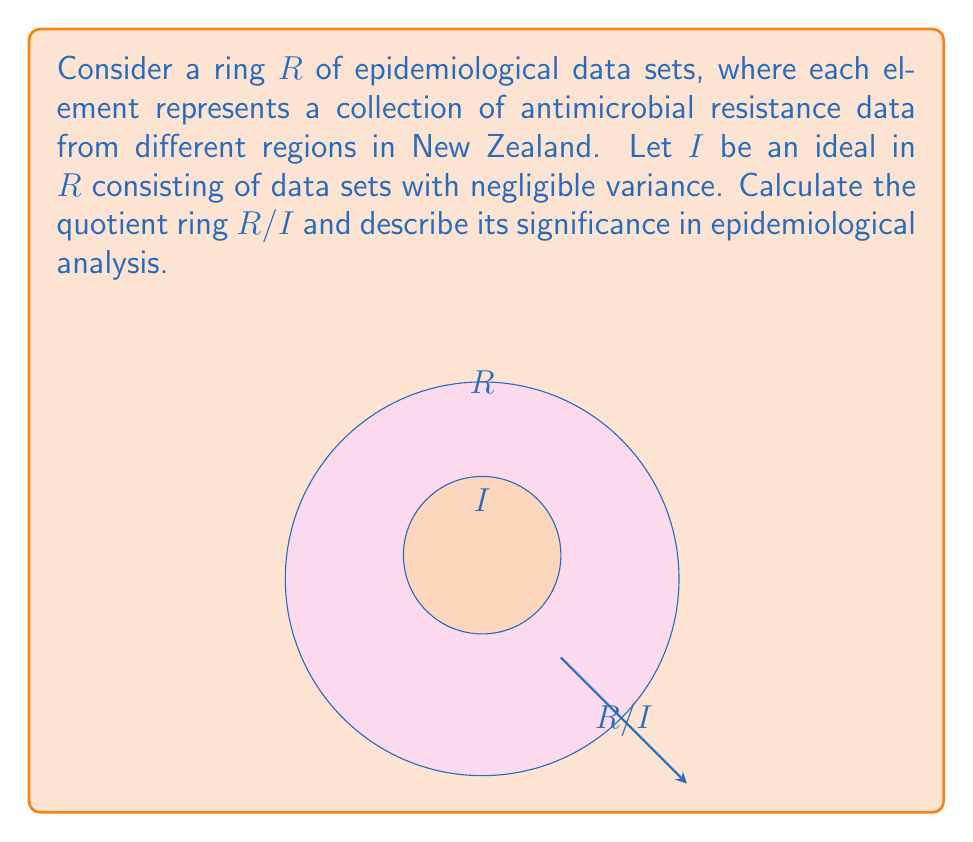What is the answer to this math problem? To calculate the quotient ring $R/I$, we follow these steps:

1) First, recall that the quotient ring $R/I$ is defined as the set of all cosets of $I$ in $R$. Each coset has the form $r + I$ for $r \in R$.

2) In this context, $R$ represents all possible antimicrobial resistance data sets from New Zealand regions, while $I$ represents the subset of these data sets with negligible variance.

3) The elements of $R/I$ are equivalence classes of data sets, where two data sets are considered equivalent if their difference has negligible variance (i.e., belongs to $I$).

4) Mathematically, we can express this as:

   $$R/I = \{[r] | r \in R\}$$
   where $[r] = \{r + i | i \in I\}$

5) In epidemiological terms, this quotient ring represents a way to classify data sets based on their significant variations, ignoring minor fluctuations.

6) The addition in $R/I$ is defined as:

   $$[a] + [b] = [a + b]$$

   This corresponds to combining data sets while preserving their significant variations.

7) The multiplication in $R/I$ is defined as:

   $$[a] \cdot [b] = [a \cdot b]$$

   This might represent more complex operations on data sets, such as correlation analysis.

8) The significance of $R/I$ in epidemiological analysis lies in its ability to highlight meaningful patterns in antimicrobial resistance data by abstracting away negligible variations, allowing researchers to focus on significant trends across different regions.
Answer: $R/I = \{[r] | r \in R\}$, where $[r]$ represents equivalence classes of data sets with significant variations in antimicrobial resistance patterns. 